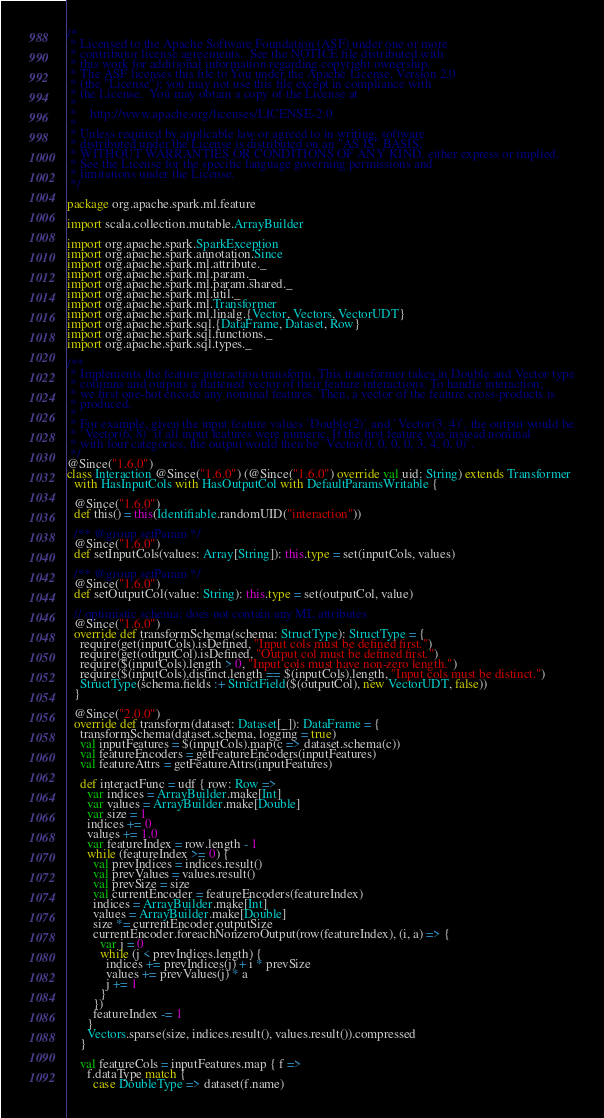Convert code to text. <code><loc_0><loc_0><loc_500><loc_500><_Scala_>/*
 * Licensed to the Apache Software Foundation (ASF) under one or more
 * contributor license agreements.  See the NOTICE file distributed with
 * this work for additional information regarding copyright ownership.
 * The ASF licenses this file to You under the Apache License, Version 2.0
 * (the "License"); you may not use this file except in compliance with
 * the License.  You may obtain a copy of the License at
 *
 *    http://www.apache.org/licenses/LICENSE-2.0
 *
 * Unless required by applicable law or agreed to in writing, software
 * distributed under the License is distributed on an "AS IS" BASIS,
 * WITHOUT WARRANTIES OR CONDITIONS OF ANY KIND, either express or implied.
 * See the License for the specific language governing permissions and
 * limitations under the License.
 */

package org.apache.spark.ml.feature

import scala.collection.mutable.ArrayBuilder

import org.apache.spark.SparkException
import org.apache.spark.annotation.Since
import org.apache.spark.ml.attribute._
import org.apache.spark.ml.param._
import org.apache.spark.ml.param.shared._
import org.apache.spark.ml.util._
import org.apache.spark.ml.Transformer
import org.apache.spark.ml.linalg.{Vector, Vectors, VectorUDT}
import org.apache.spark.sql.{DataFrame, Dataset, Row}
import org.apache.spark.sql.functions._
import org.apache.spark.sql.types._

/**
 * Implements the feature interaction transform. This transformer takes in Double and Vector type
 * columns and outputs a flattened vector of their feature interactions. To handle interaction,
 * we first one-hot encode any nominal features. Then, a vector of the feature cross-products is
 * produced.
 *
 * For example, given the input feature values `Double(2)` and `Vector(3, 4)`, the output would be
 * `Vector(6, 8)` if all input features were numeric. If the first feature was instead nominal
 * with four categories, the output would then be `Vector(0, 0, 0, 0, 3, 4, 0, 0)`.
 */
@Since("1.6.0")
class Interaction @Since("1.6.0") (@Since("1.6.0") override val uid: String) extends Transformer
  with HasInputCols with HasOutputCol with DefaultParamsWritable {

  @Since("1.6.0")
  def this() = this(Identifiable.randomUID("interaction"))

  /** @group setParam */
  @Since("1.6.0")
  def setInputCols(values: Array[String]): this.type = set(inputCols, values)

  /** @group setParam */
  @Since("1.6.0")
  def setOutputCol(value: String): this.type = set(outputCol, value)

  // optimistic schema; does not contain any ML attributes
  @Since("1.6.0")
  override def transformSchema(schema: StructType): StructType = {
    require(get(inputCols).isDefined, "Input cols must be defined first.")
    require(get(outputCol).isDefined, "Output col must be defined first.")
    require($(inputCols).length > 0, "Input cols must have non-zero length.")
    require($(inputCols).distinct.length == $(inputCols).length, "Input cols must be distinct.")
    StructType(schema.fields :+ StructField($(outputCol), new VectorUDT, false))
  }

  @Since("2.0.0")
  override def transform(dataset: Dataset[_]): DataFrame = {
    transformSchema(dataset.schema, logging = true)
    val inputFeatures = $(inputCols).map(c => dataset.schema(c))
    val featureEncoders = getFeatureEncoders(inputFeatures)
    val featureAttrs = getFeatureAttrs(inputFeatures)

    def interactFunc = udf { row: Row =>
      var indices = ArrayBuilder.make[Int]
      var values = ArrayBuilder.make[Double]
      var size = 1
      indices += 0
      values += 1.0
      var featureIndex = row.length - 1
      while (featureIndex >= 0) {
        val prevIndices = indices.result()
        val prevValues = values.result()
        val prevSize = size
        val currentEncoder = featureEncoders(featureIndex)
        indices = ArrayBuilder.make[Int]
        values = ArrayBuilder.make[Double]
        size *= currentEncoder.outputSize
        currentEncoder.foreachNonzeroOutput(row(featureIndex), (i, a) => {
          var j = 0
          while (j < prevIndices.length) {
            indices += prevIndices(j) + i * prevSize
            values += prevValues(j) * a
            j += 1
          }
        })
        featureIndex -= 1
      }
      Vectors.sparse(size, indices.result(), values.result()).compressed
    }

    val featureCols = inputFeatures.map { f =>
      f.dataType match {
        case DoubleType => dataset(f.name)</code> 